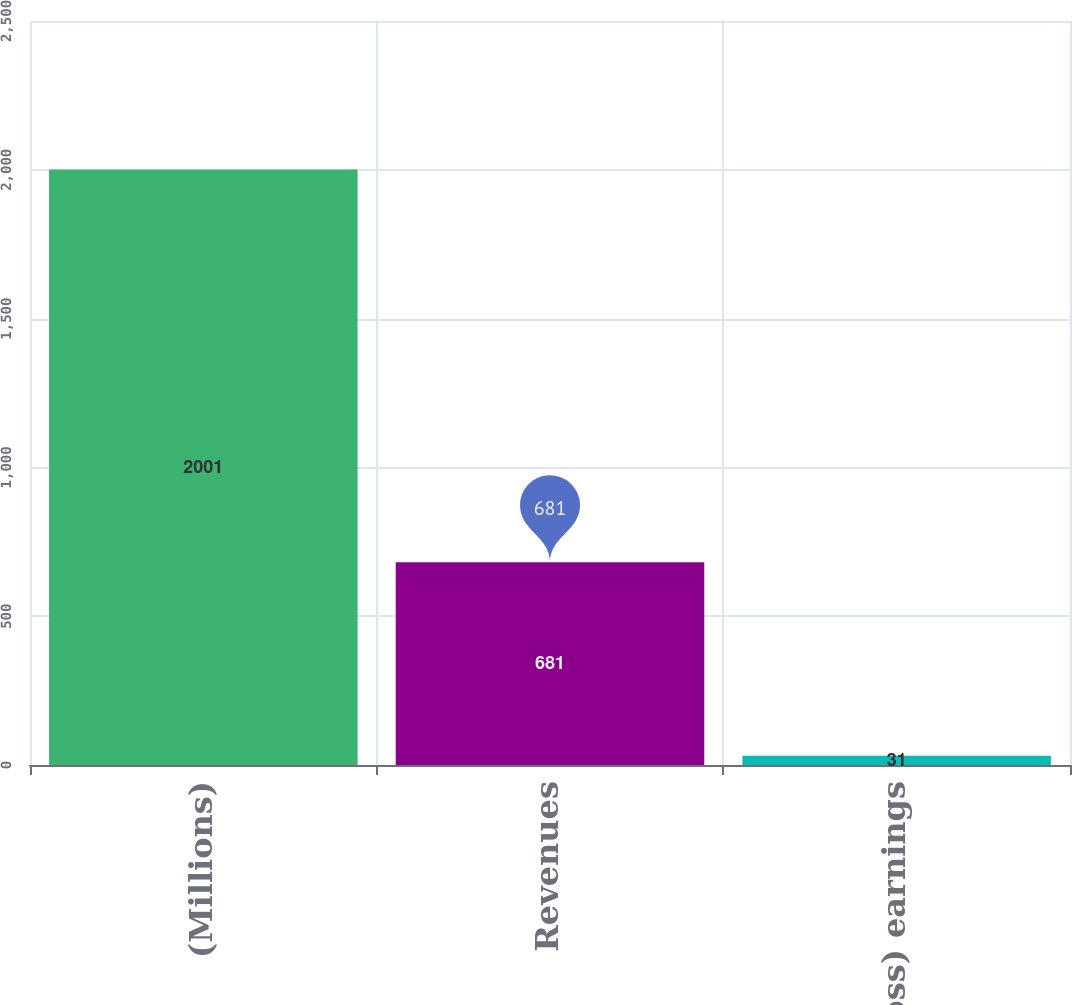<chart> <loc_0><loc_0><loc_500><loc_500><bar_chart><fcel>(Millions)<fcel>Revenues<fcel>Net (loss) earnings<nl><fcel>2001<fcel>681<fcel>31<nl></chart> 